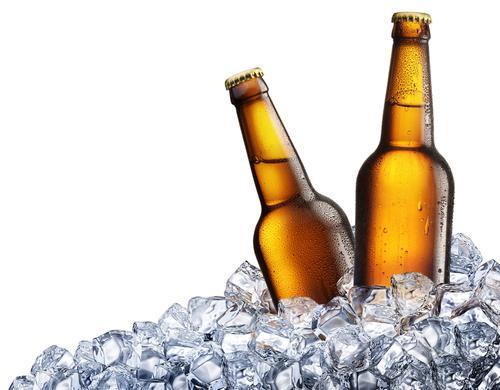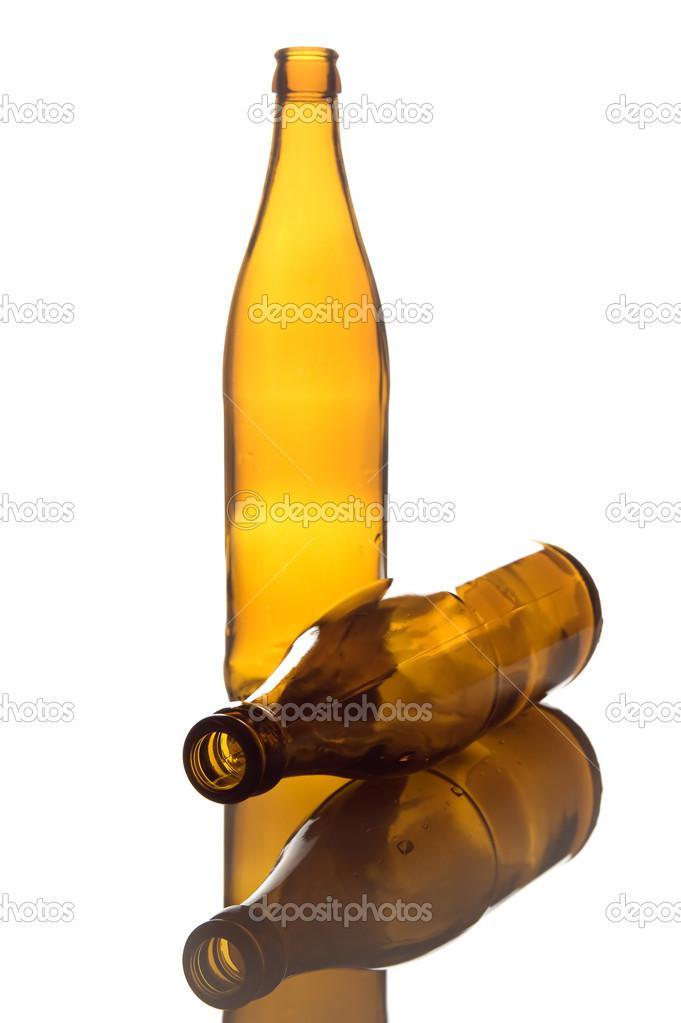The first image is the image on the left, the second image is the image on the right. Assess this claim about the two images: "In one image, at least two beer bottles are capped and ice, but do not have a label.". Correct or not? Answer yes or no. Yes. The first image is the image on the left, the second image is the image on the right. Analyze the images presented: Is the assertion "Bottles are protruding from a pile of ice." valid? Answer yes or no. Yes. 